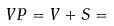Convert formula to latex. <formula><loc_0><loc_0><loc_500><loc_500>V P = V + S =</formula> 